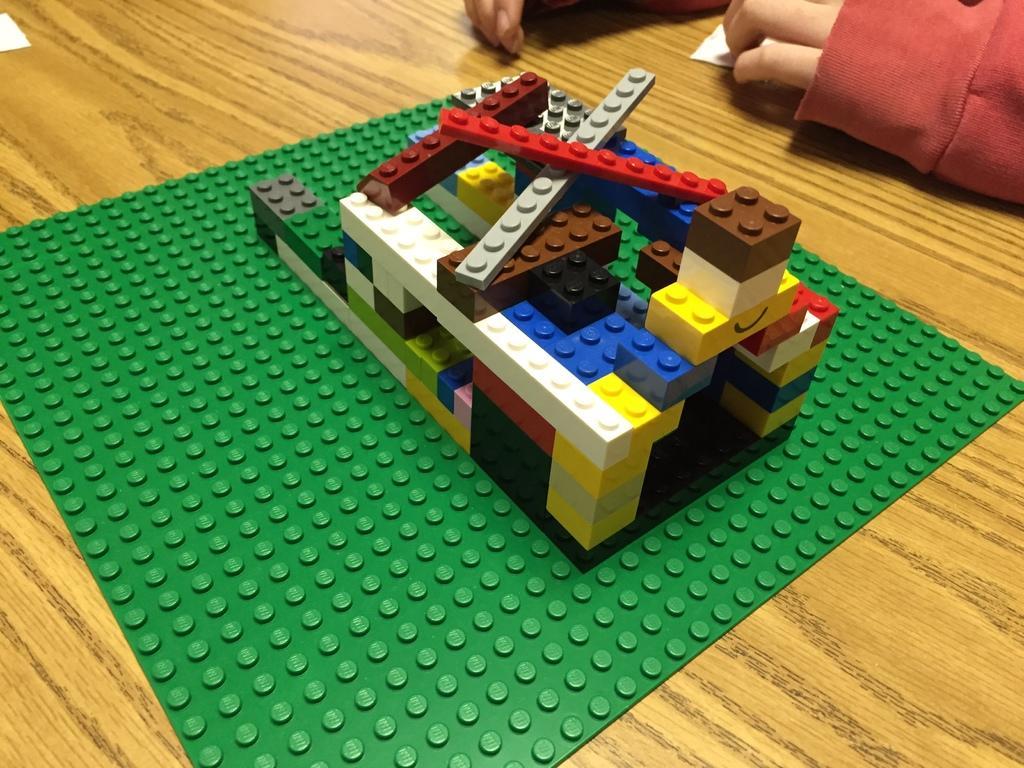How would you summarize this image in a sentence or two? In this picture there are buildings blocks on the table and there is a person behind the table and at the top left there is a paper on the table. 